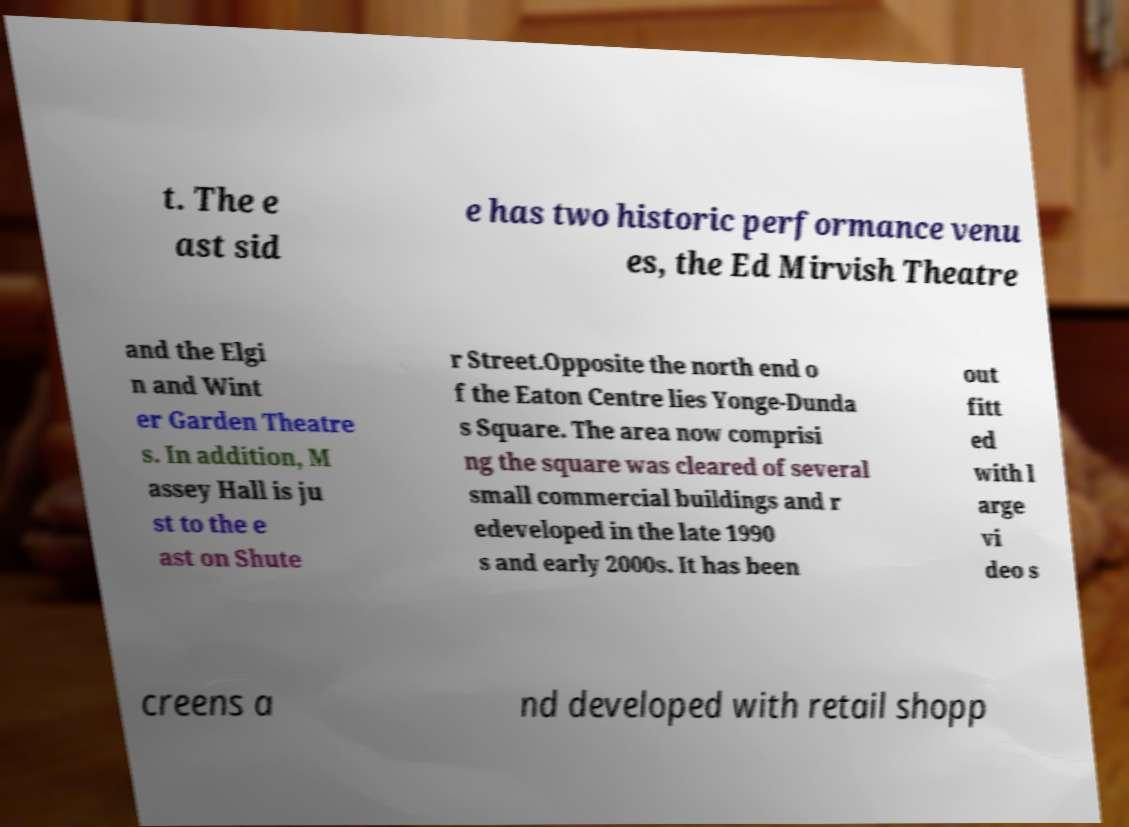Could you extract and type out the text from this image? t. The e ast sid e has two historic performance venu es, the Ed Mirvish Theatre and the Elgi n and Wint er Garden Theatre s. In addition, M assey Hall is ju st to the e ast on Shute r Street.Opposite the north end o f the Eaton Centre lies Yonge-Dunda s Square. The area now comprisi ng the square was cleared of several small commercial buildings and r edeveloped in the late 1990 s and early 2000s. It has been out fitt ed with l arge vi deo s creens a nd developed with retail shopp 